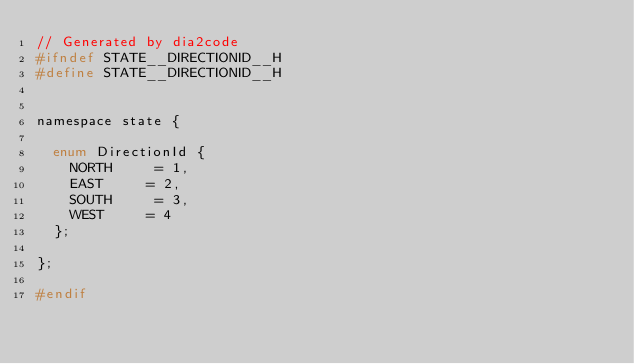Convert code to text. <code><loc_0><loc_0><loc_500><loc_500><_C_>// Generated by dia2code
#ifndef STATE__DIRECTIONID__H
#define STATE__DIRECTIONID__H


namespace state {

  enum DirectionId {
    NORTH     = 1,
    EAST     = 2,
    SOUTH     = 3,
    WEST     = 4
  };

};

#endif
</code> 